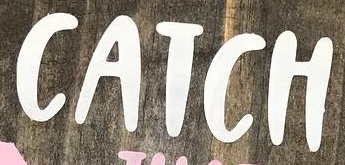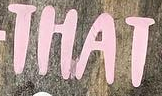Identify the words shown in these images in order, separated by a semicolon. CATCH; THAT 